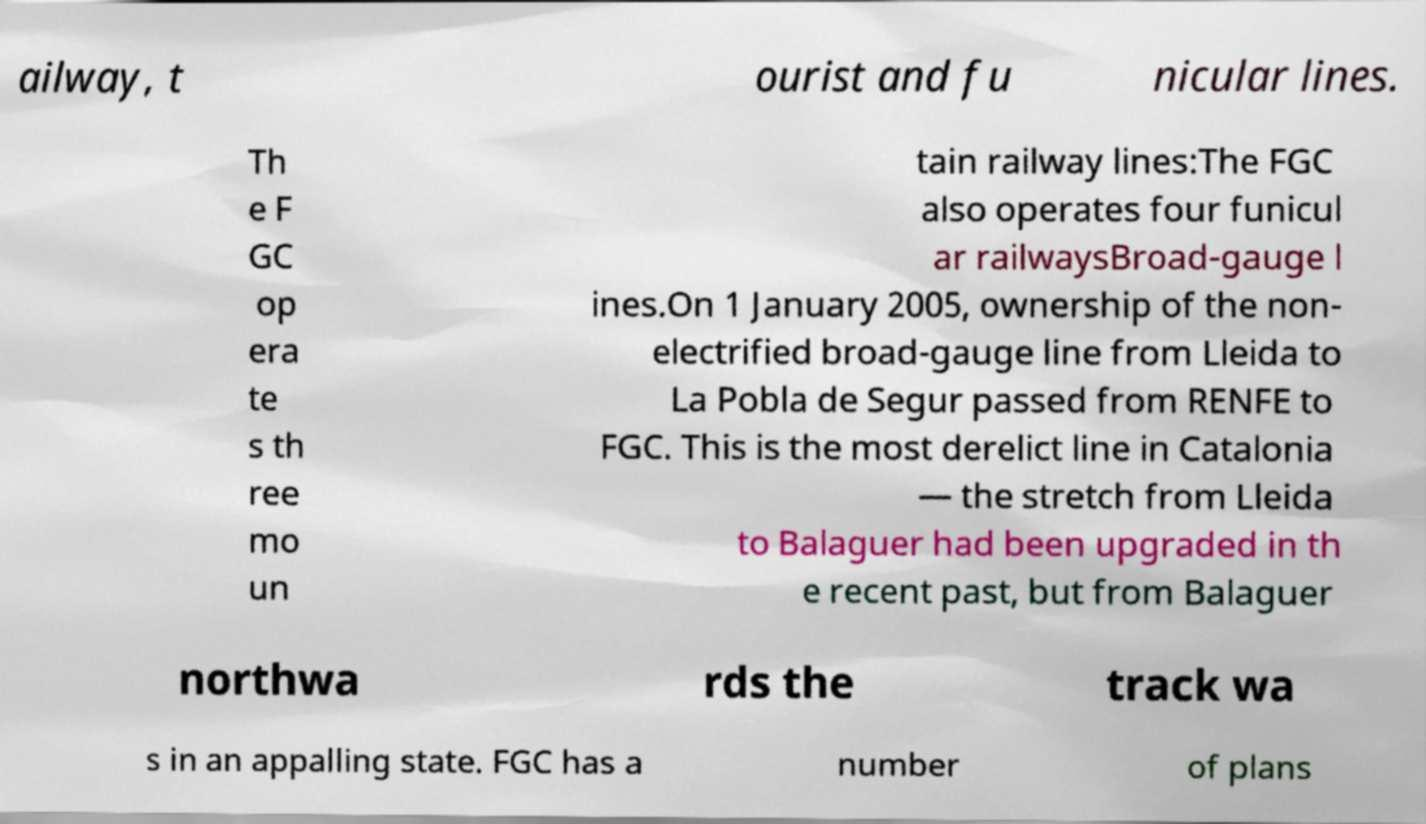For documentation purposes, I need the text within this image transcribed. Could you provide that? ailway, t ourist and fu nicular lines. Th e F GC op era te s th ree mo un tain railway lines:The FGC also operates four funicul ar railwaysBroad-gauge l ines.On 1 January 2005, ownership of the non- electrified broad-gauge line from Lleida to La Pobla de Segur passed from RENFE to FGC. This is the most derelict line in Catalonia — the stretch from Lleida to Balaguer had been upgraded in th e recent past, but from Balaguer northwa rds the track wa s in an appalling state. FGC has a number of plans 